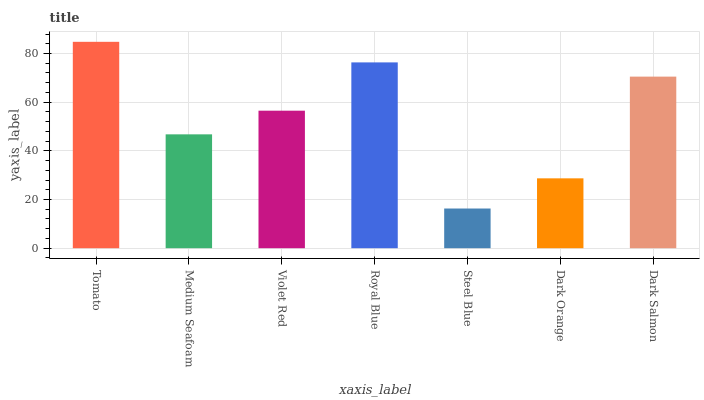Is Steel Blue the minimum?
Answer yes or no. Yes. Is Tomato the maximum?
Answer yes or no. Yes. Is Medium Seafoam the minimum?
Answer yes or no. No. Is Medium Seafoam the maximum?
Answer yes or no. No. Is Tomato greater than Medium Seafoam?
Answer yes or no. Yes. Is Medium Seafoam less than Tomato?
Answer yes or no. Yes. Is Medium Seafoam greater than Tomato?
Answer yes or no. No. Is Tomato less than Medium Seafoam?
Answer yes or no. No. Is Violet Red the high median?
Answer yes or no. Yes. Is Violet Red the low median?
Answer yes or no. Yes. Is Tomato the high median?
Answer yes or no. No. Is Dark Orange the low median?
Answer yes or no. No. 